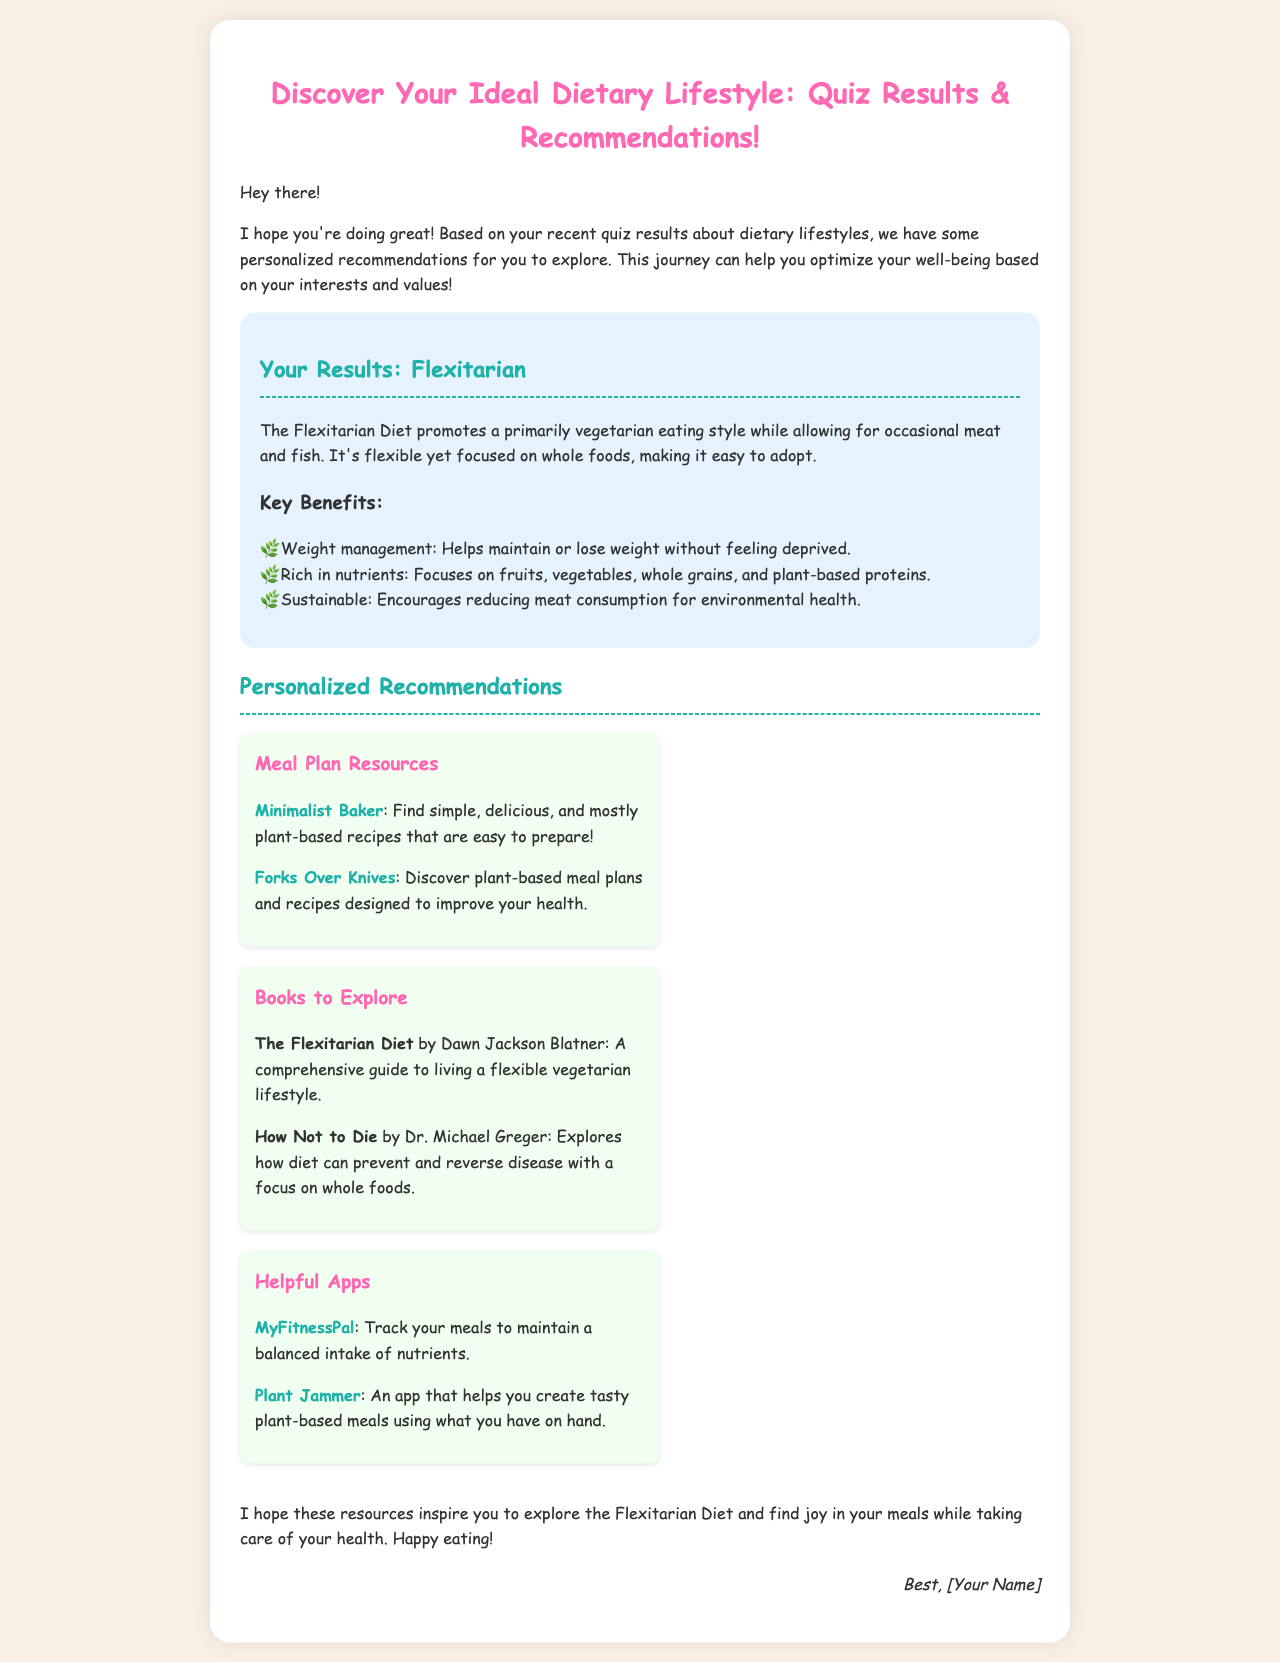What dietary lifestyle does the quiz result recommend? The document states that the results recommend the Flexitarian Diet.
Answer: Flexitarian What is a key benefit of the Flexitarian Diet? A key benefit mentioned is that it helps maintain or lose weight without feeling deprived.
Answer: Weight management Which book is recommended for exploring the Flexitarian Diet? The document lists "The Flexitarian Diet" by Dawn Jackson Blatner as a recommended book.
Answer: The Flexitarian Diet What is one of the suggested meal plan resources? "Forks Over Knives" is mentioned in the document as a resource for plant-based meal plans.
Answer: Forks Over Knives How many recommendations for helpful apps are provided? The document provides a total of two recommendations for helpful apps.
Answer: Two 